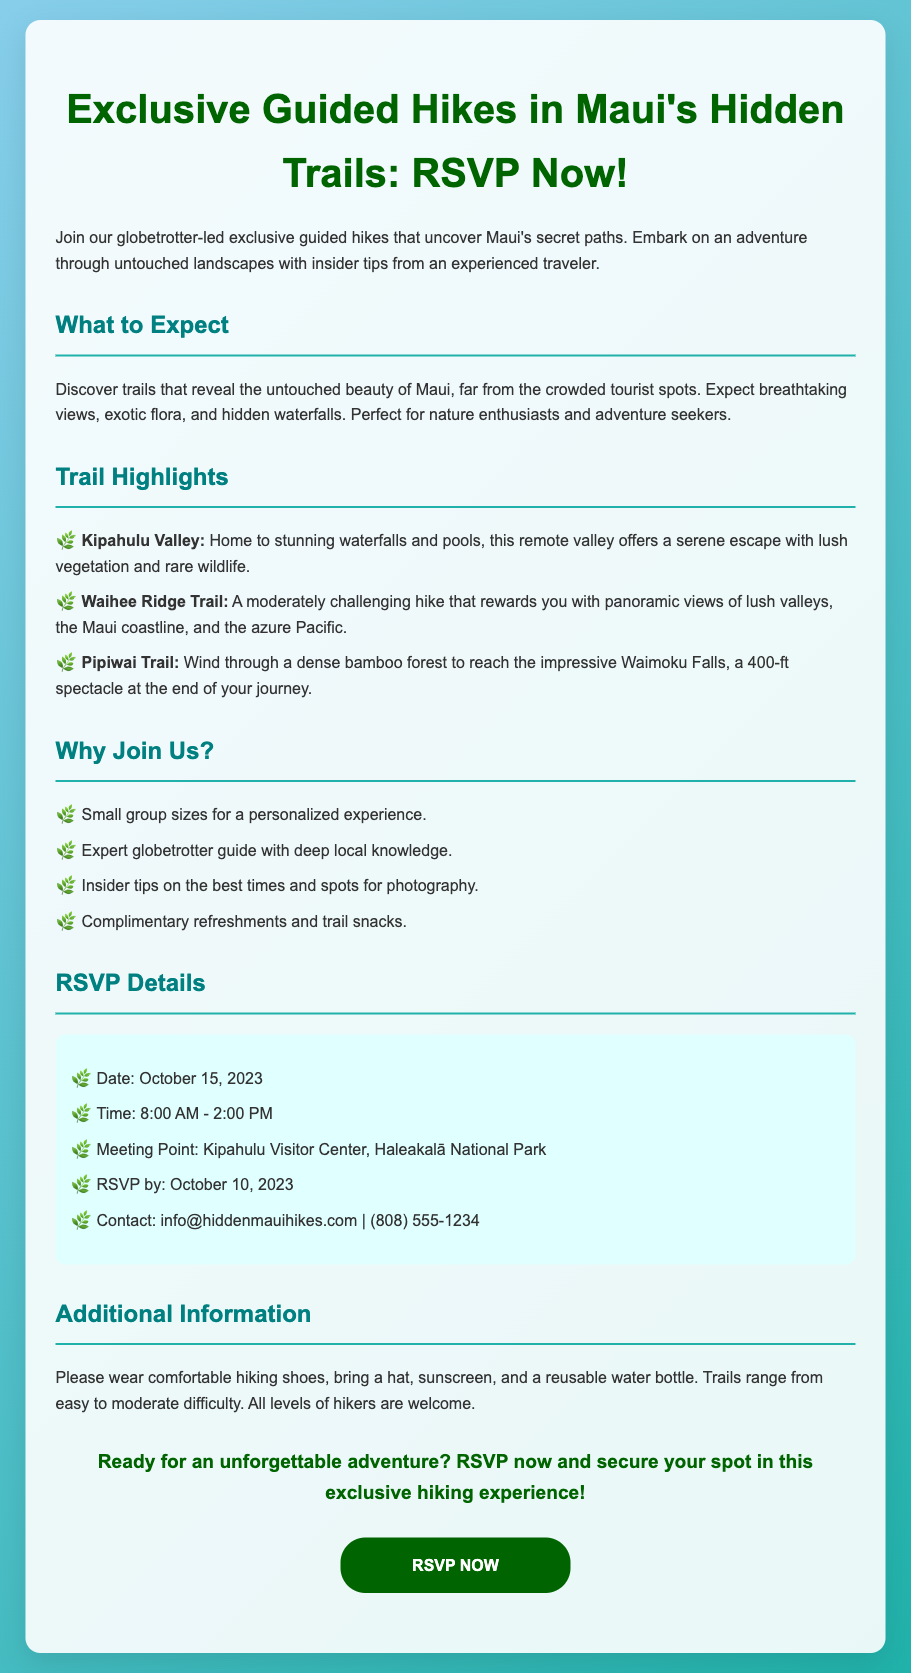What is the date of the event? The date of the event is specified in the RSVP details section of the document.
Answer: October 15, 2023 Where is the meeting point? The meeting point for the hike is noted in the RSVP details.
Answer: Kipahulu Visitor Center, Haleakalā National Park What time does the hike start? The start time of the hike can be found in the RSVP details section.
Answer: 8:00 AM Who can join the hikes? The document mentions the level of hiker that can join, found in the additional information section.
Answer: All levels of hikers What is a highlight of the Waihee Ridge Trail? The highlights of the trails are listed in the Trail Highlights section.
Answer: Panoramic views of lush valleys Why are small group sizes emphasized? The reason for small group sizes is mentioned under the "Why Join Us?" section.
Answer: Personalized experience What should participants bring? The document specifies items to bring in the additional information section.
Answer: Comfortable hiking shoes, hat, sunscreen, reusable water bottle When is the RSVP deadline? The deadline for RSVPs is listed in the RSVP details section of the document.
Answer: October 10, 2023 What is offered along the trail? Complimentary items provided are specified in the "Why Join Us?" section.
Answer: Refreshments and trail snacks 